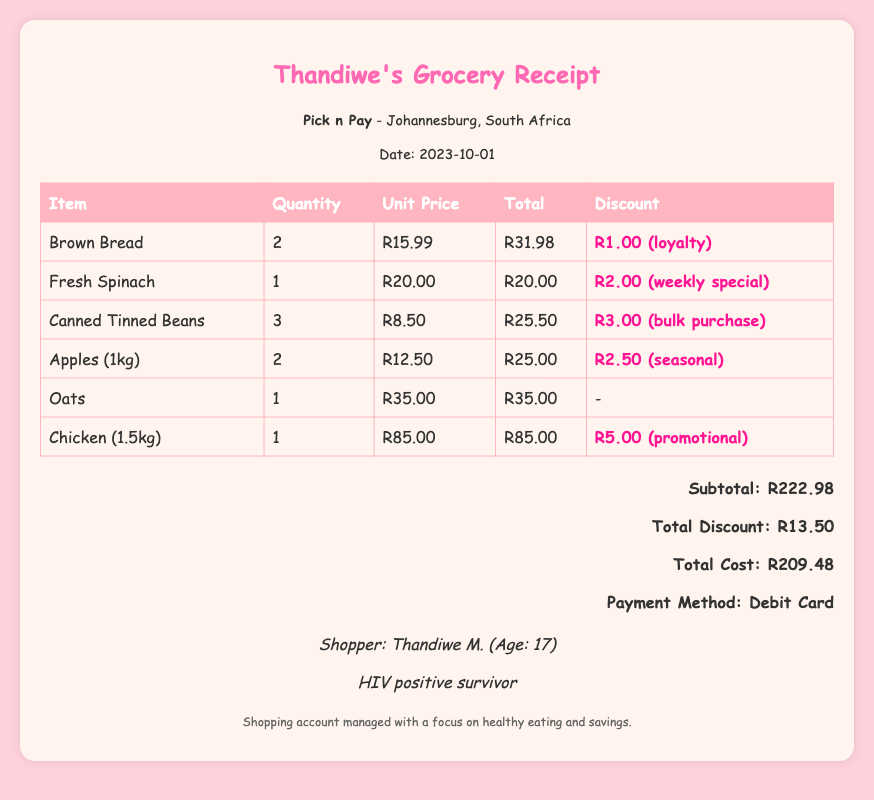What is the total cost? The total cost is provided in the document as the final amount after discounts have been applied.
Answer: R209.48 What is the discount on Brown Bread? The discount for Brown Bread is noted in the item details, showing how much was deducted from the total price.
Answer: R1.00 (loyalty) How many items were purchased in total? This requires counting the line items listed in the items table of the document.
Answer: 6 Who is the shopper? The shopper's name is given in the document, along with additional details about her.
Answer: Thandiwe M What is the subtotal amount before discounts? This represents the total amount of all items before any discounts are deducted, as shown in the total section.
Answer: R222.98 What was the discount applied for canned tinned beans? This asks for the specific discount provided for the canned tinned beans, found in the discount column.
Answer: R3.00 (bulk purchase) What location is the grocery store in? The location of the grocery store is clearly specified in the store information section of the document.
Answer: Johannesburg, South Africa What was the payment method used? This information is included in the total section of the document detailing how the payment was made.
Answer: Debit Card 